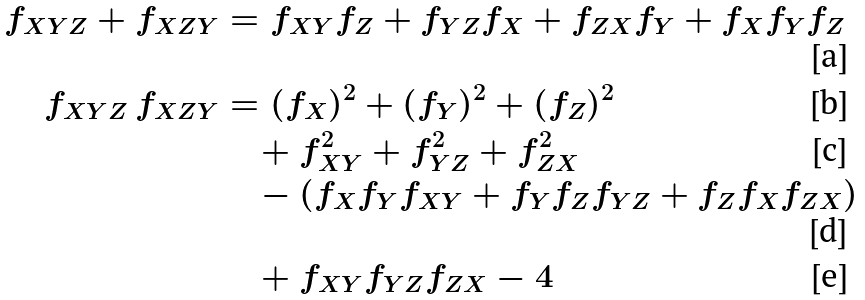Convert formula to latex. <formula><loc_0><loc_0><loc_500><loc_500>f _ { X Y Z } + f _ { X Z Y } & = f _ { X Y } f _ { Z } + f _ { Y Z } f _ { X } + f _ { Z X } f _ { Y } + f _ { X } f _ { Y } f _ { Z } \\ f _ { X Y Z } \, f _ { X Z Y } & = ( f _ { X } ) ^ { 2 } + ( f _ { Y } ) ^ { 2 } + ( f _ { Z } ) ^ { 2 } \\ & \quad + f _ { X Y } ^ { 2 } + f _ { Y Z } ^ { 2 } + f _ { Z X } ^ { 2 } \\ & \quad - ( f _ { X } f _ { Y } f _ { X Y } + f _ { Y } f _ { Z } f _ { Y Z } + f _ { Z } f _ { X } f _ { Z X } ) \\ & \quad + f _ { X Y } f _ { Y Z } f _ { Z X } - 4</formula> 